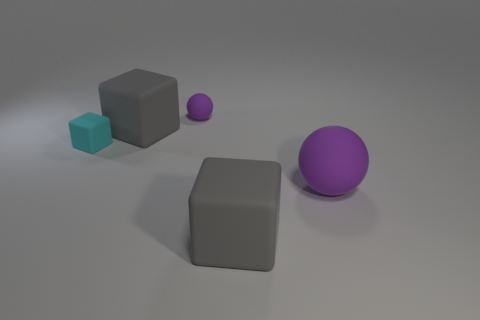How many large blocks are the same color as the small ball?
Offer a very short reply. 0. Is there any other thing of the same color as the small rubber ball?
Offer a very short reply. Yes. What material is the small purple thing?
Give a very brief answer. Rubber. There is a small ball; does it have the same color as the big rubber sphere that is in front of the tiny purple matte sphere?
Keep it short and to the point. Yes. There is a tiny ball; what number of tiny matte spheres are right of it?
Your response must be concise. 0. Is the number of tiny cyan rubber objects left of the small purple rubber object less than the number of spheres?
Provide a succinct answer. Yes. What color is the large ball?
Keep it short and to the point. Purple. Is the color of the ball behind the large purple ball the same as the large rubber sphere?
Provide a succinct answer. Yes. There is a big matte thing that is the same shape as the tiny purple matte thing; what color is it?
Your answer should be very brief. Purple. How many big objects are purple spheres or brown cubes?
Provide a short and direct response. 1. 